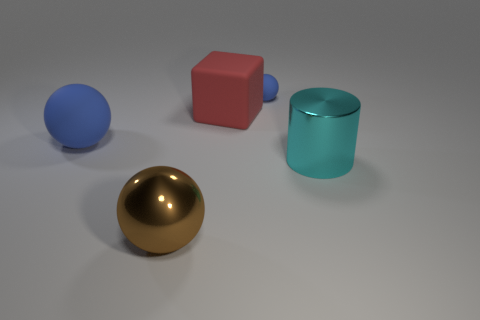Add 4 purple metal balls. How many objects exist? 9 Subtract all blocks. How many objects are left? 4 Subtract 1 red blocks. How many objects are left? 4 Subtract all blue things. Subtract all brown matte things. How many objects are left? 3 Add 3 brown balls. How many brown balls are left? 4 Add 5 small cyan matte cubes. How many small cyan matte cubes exist? 5 